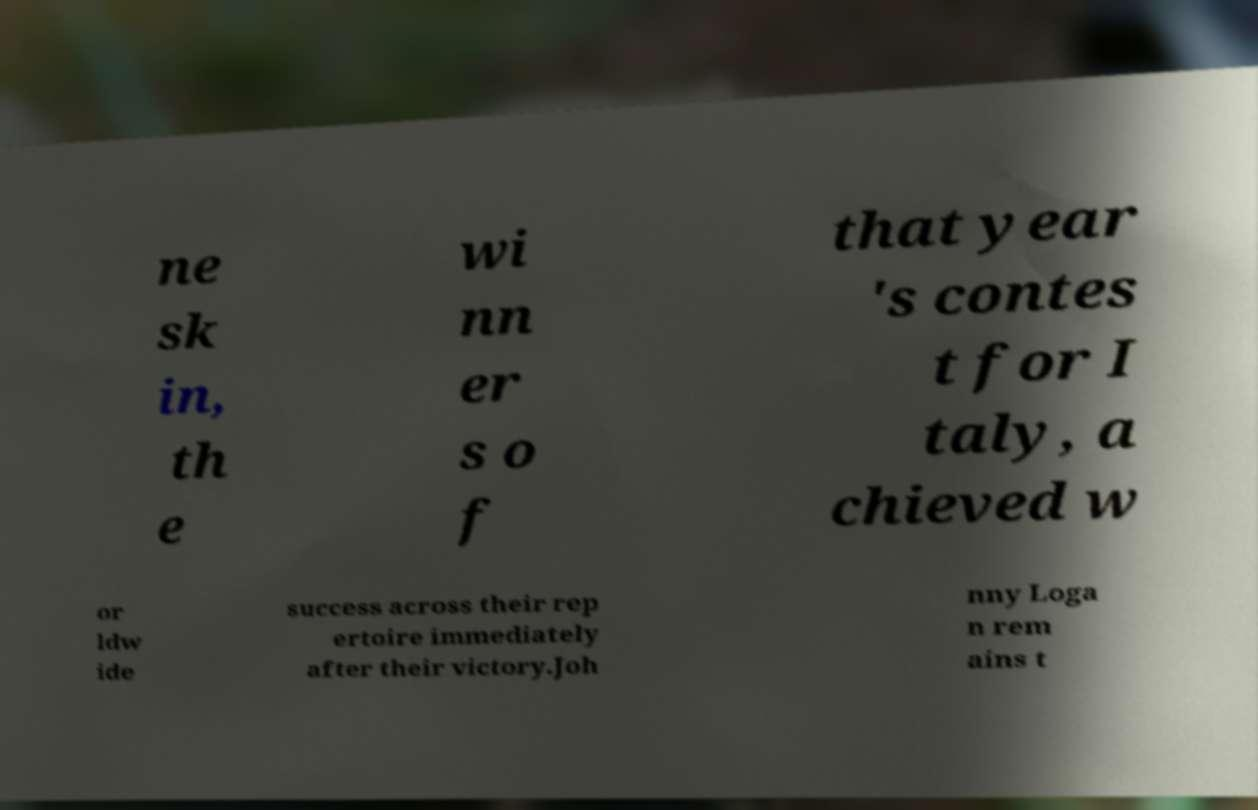Can you read and provide the text displayed in the image?This photo seems to have some interesting text. Can you extract and type it out for me? ne sk in, th e wi nn er s o f that year 's contes t for I taly, a chieved w or ldw ide success across their rep ertoire immediately after their victory.Joh nny Loga n rem ains t 